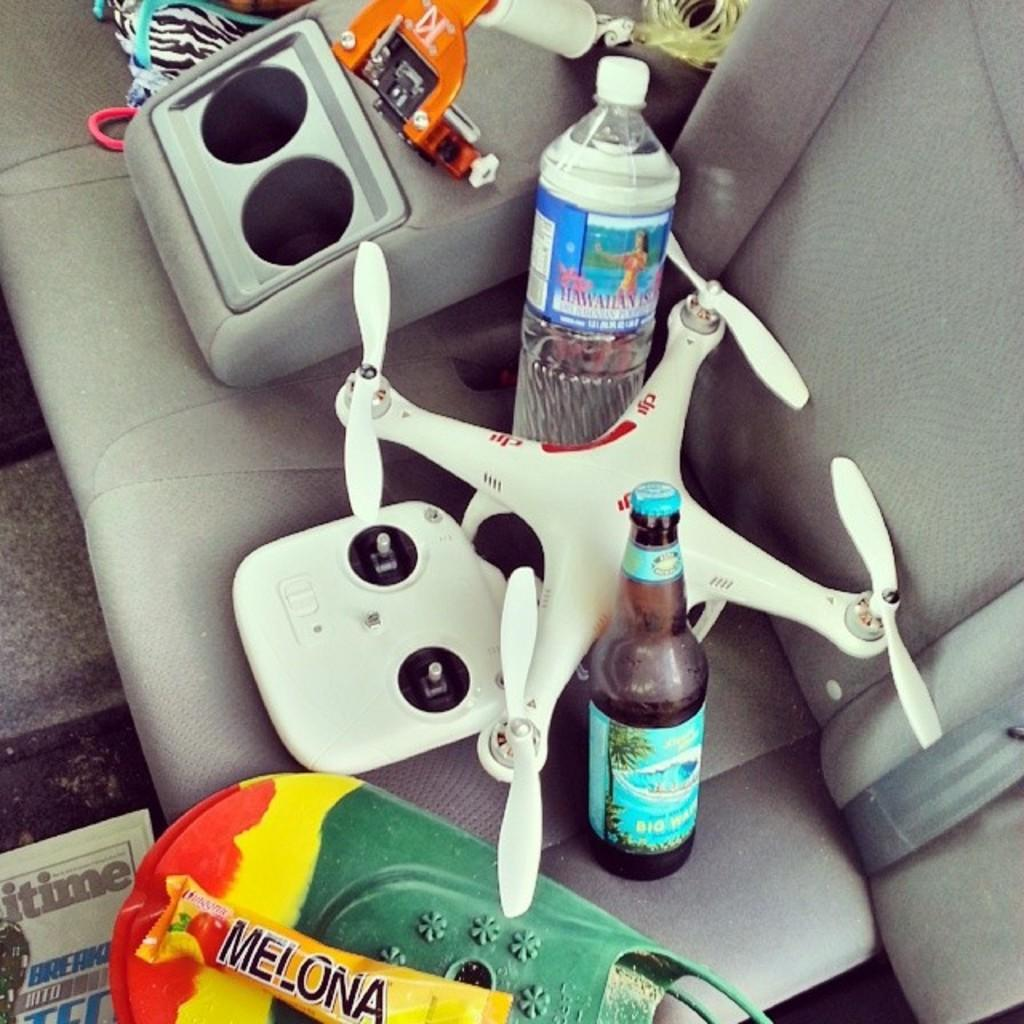<image>
Offer a succinct explanation of the picture presented. A remote control drone is on a car seat with bottles and a Melona candy bar. 